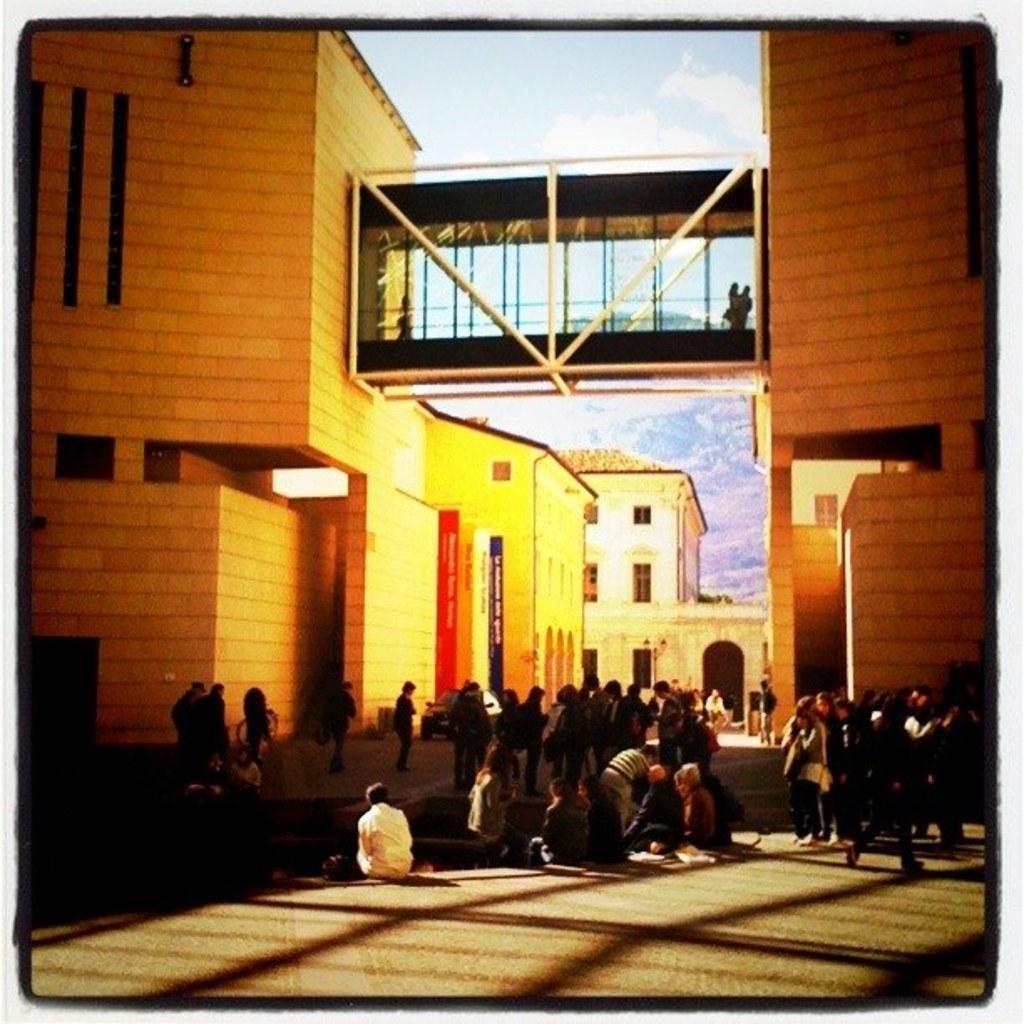Can you describe this image briefly? This is an edited image. There are few people sitting and groups of people standing. I can see a walkway between two buildings. In the background, I can see another building and there is the sky. 